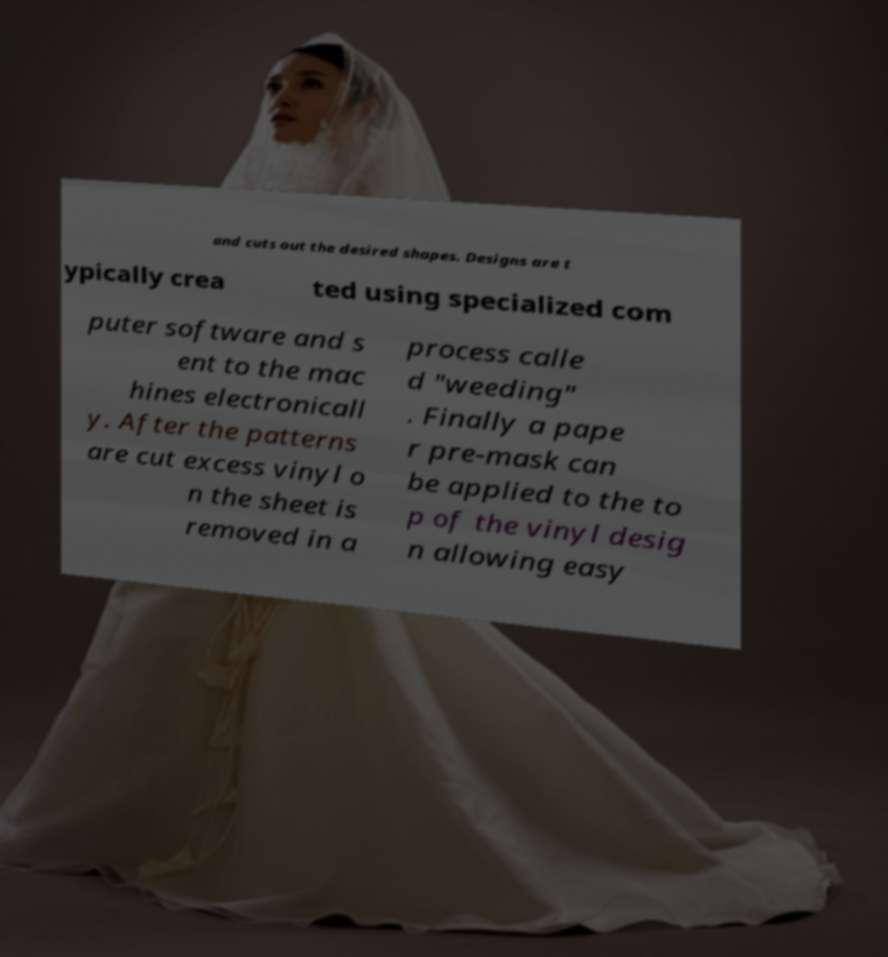For documentation purposes, I need the text within this image transcribed. Could you provide that? and cuts out the desired shapes. Designs are t ypically crea ted using specialized com puter software and s ent to the mac hines electronicall y. After the patterns are cut excess vinyl o n the sheet is removed in a process calle d "weeding" . Finally a pape r pre-mask can be applied to the to p of the vinyl desig n allowing easy 